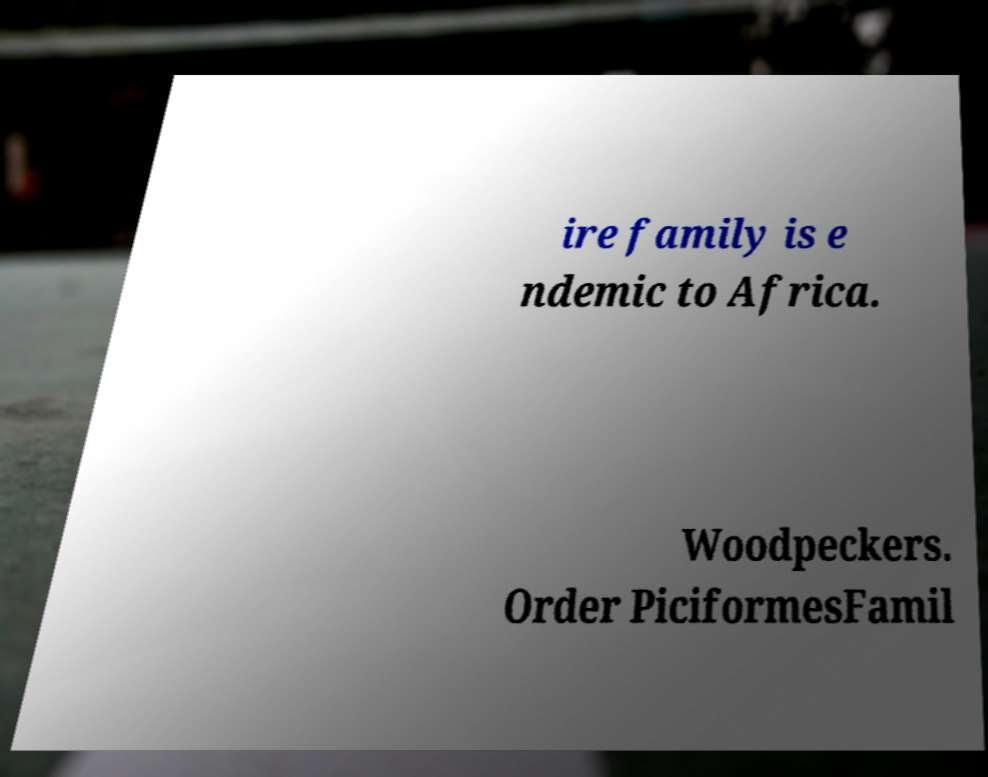There's text embedded in this image that I need extracted. Can you transcribe it verbatim? ire family is e ndemic to Africa. Woodpeckers. Order PiciformesFamil 